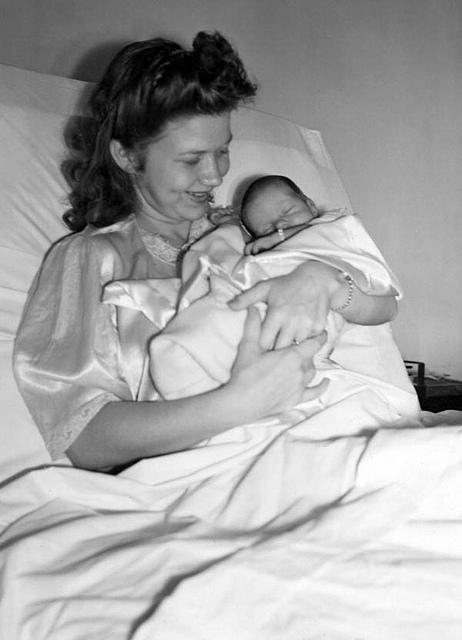Is this person reading a book?
Short answer required. No. Is the woman hugging a baby?
Keep it brief. Yes. Is the blanket patterned?
Be succinct. No. Is the woman wearing glasses?
Keep it brief. No. What is on the woman's lap?
Concise answer only. Baby. What is this person holding?
Keep it brief. Baby. What year was the picture taken?
Give a very brief answer. 1950. Is there room for another person on the bed in this scene?
Write a very short answer. No. What is the lady holding?
Give a very brief answer. Baby. Is she sitting up in bed?
Quick response, please. Yes. 